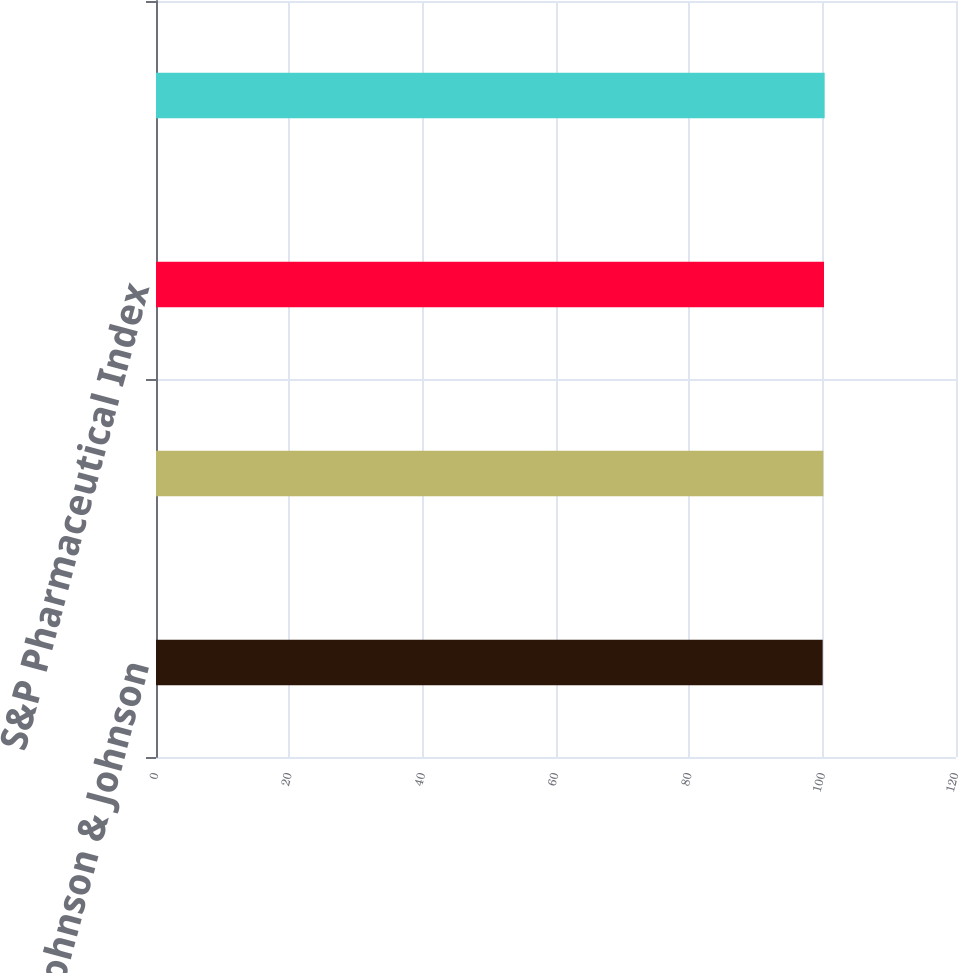Convert chart to OTSL. <chart><loc_0><loc_0><loc_500><loc_500><bar_chart><fcel>Johnson & Johnson<fcel>S&P 500 Index<fcel>S&P Pharmaceutical Index<fcel>S&P Healthcare Equipment Index<nl><fcel>100<fcel>100.1<fcel>100.2<fcel>100.3<nl></chart> 